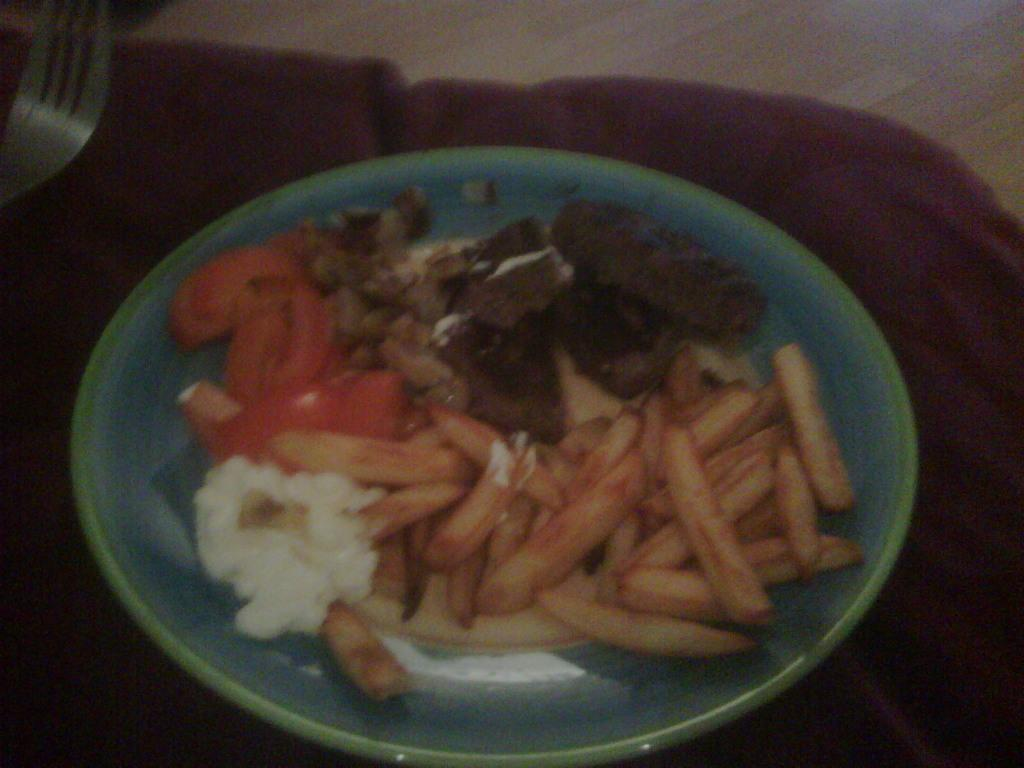What is on the plate that is visible in the image? There are french fries on the plate, along with other food items. What utensil is present in the image? There is a fork in the image. Where are the plate and fork located? Both the plate and fork are on a table. How many trucks are parked next to the table in the image? There are no trucks present in the image; it only features a plate, fork, and food items on a table. Is there a rat hiding under the table in the image? There is no rat present in the image; it only features a plate, fork, and food items on a table. 